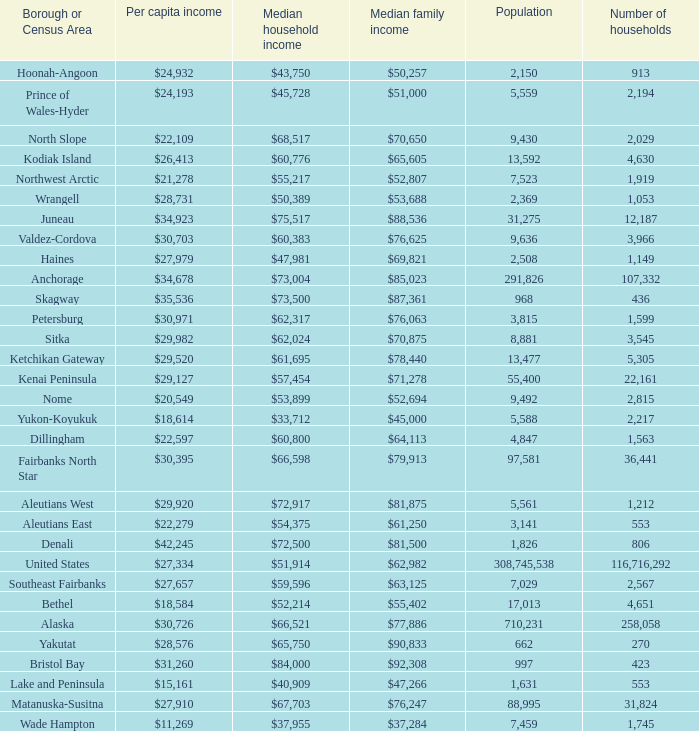Which borough or census area has a $59,596 median household income? Southeast Fairbanks. 